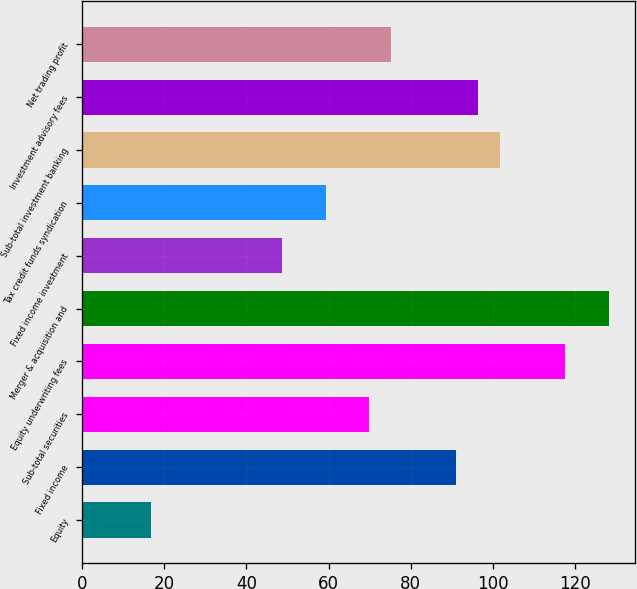<chart> <loc_0><loc_0><loc_500><loc_500><bar_chart><fcel>Equity<fcel>Fixed income<fcel>Sub-total securities<fcel>Equity underwriting fees<fcel>Merger & acquisition and<fcel>Fixed income investment<fcel>Tax credit funds syndication<fcel>Sub-total investment banking<fcel>Investment advisory fees<fcel>Net trading profit<nl><fcel>16.9<fcel>91.1<fcel>69.9<fcel>117.6<fcel>128.2<fcel>48.7<fcel>59.3<fcel>101.7<fcel>96.4<fcel>75.2<nl></chart> 